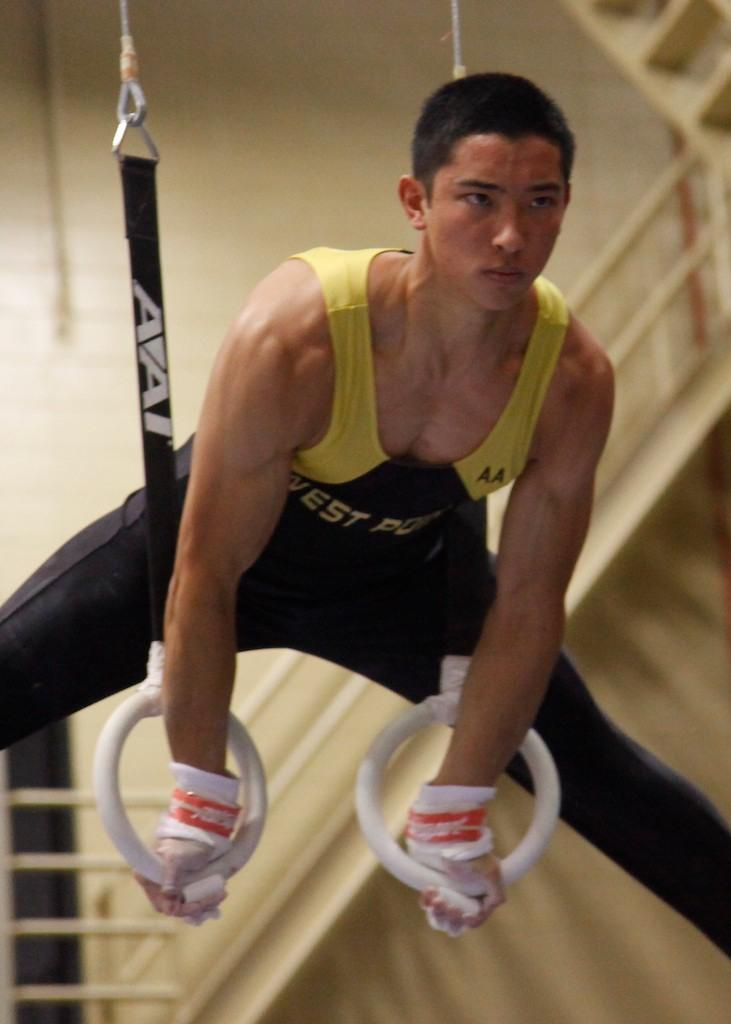<image>
Give a short and clear explanation of the subsequent image. A man wearing a West Point tank top practicing gymnastics. 